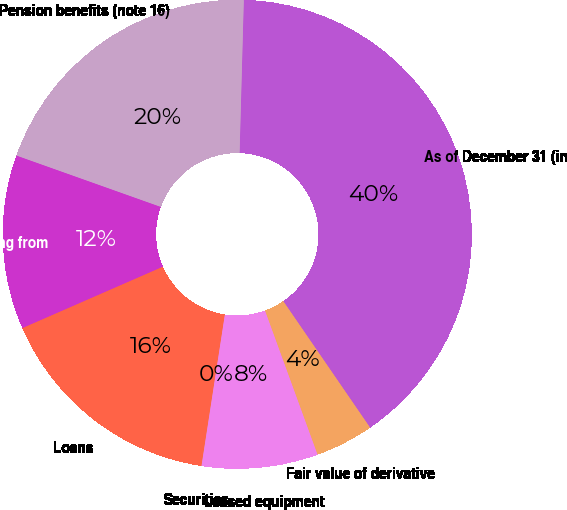Convert chart. <chart><loc_0><loc_0><loc_500><loc_500><pie_chart><fcel>As of December 31 (in<fcel>Pension benefits (note 16)<fcel>Receivables arising from<fcel>Loans<fcel>Securities<fcel>Leased equipment<fcel>Fair value of derivative<nl><fcel>39.99%<fcel>20.0%<fcel>12.0%<fcel>16.0%<fcel>0.01%<fcel>8.0%<fcel>4.01%<nl></chart> 